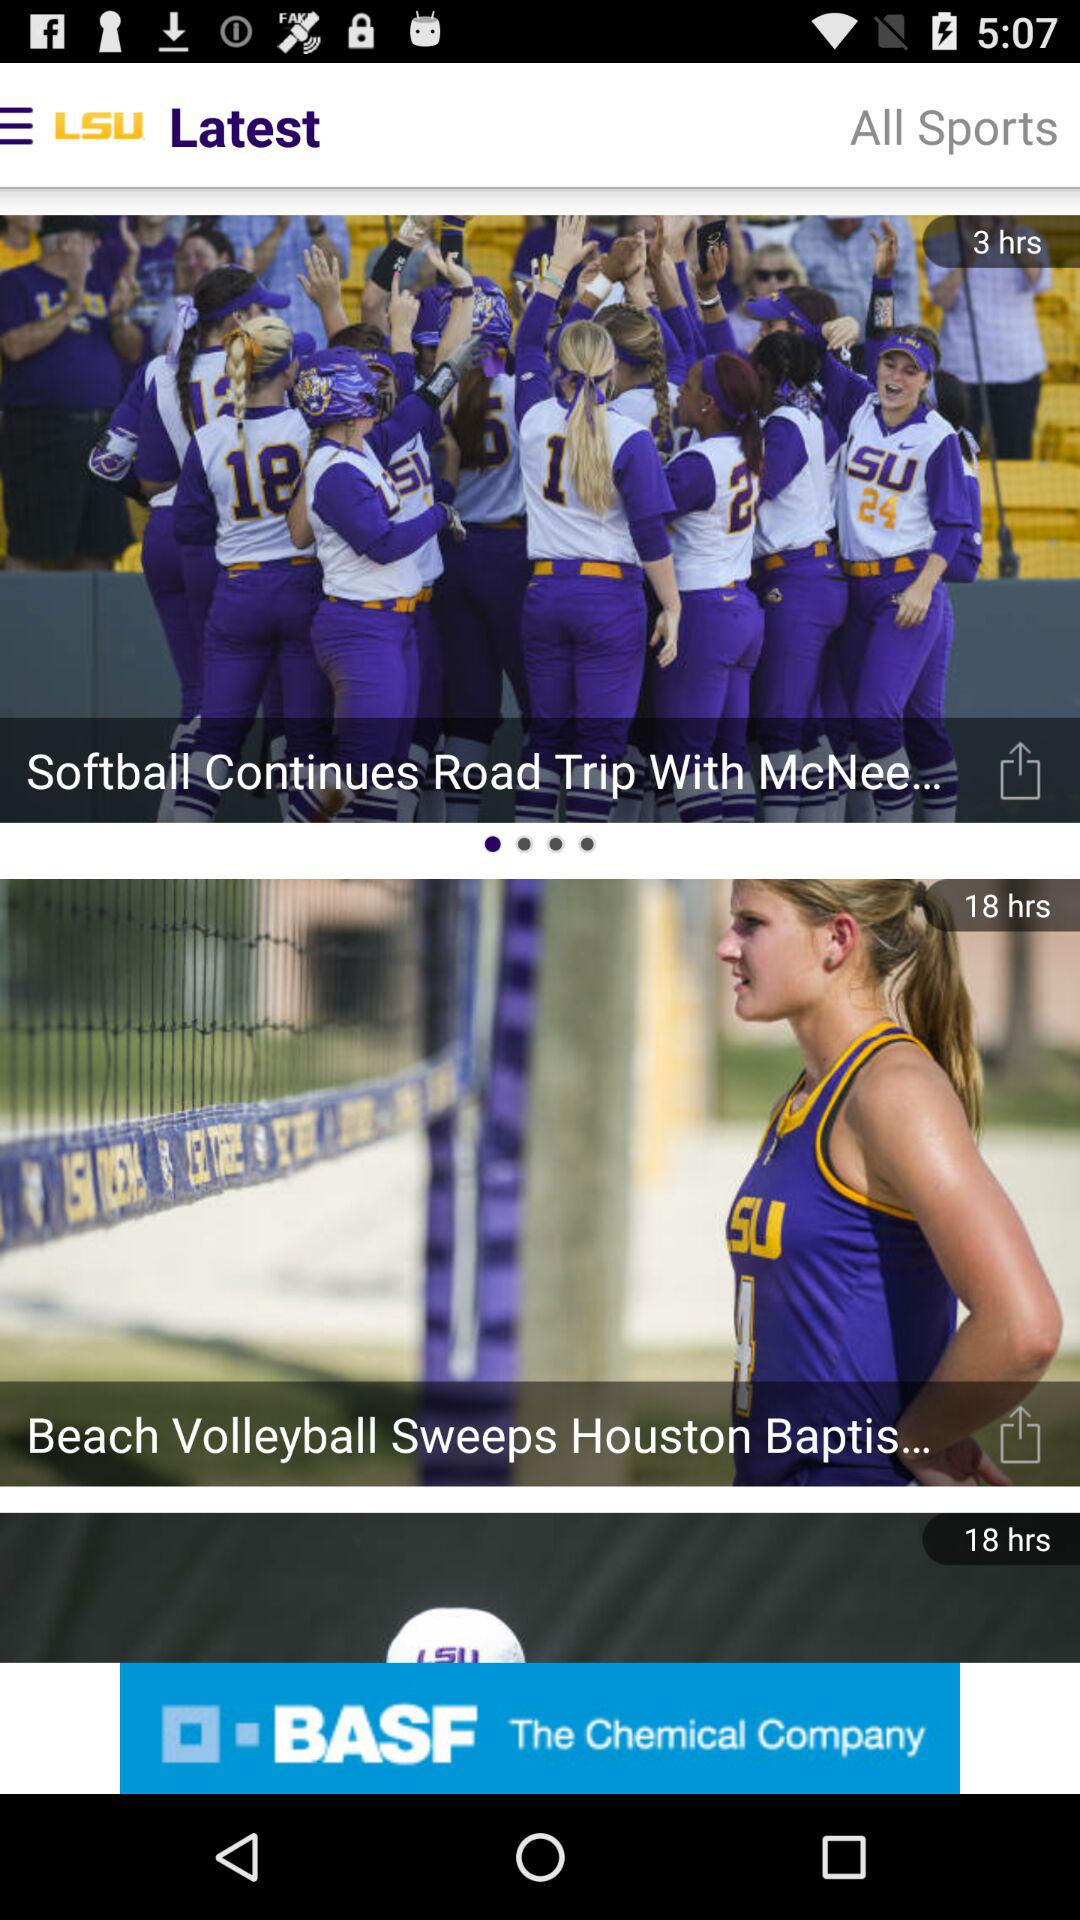What is the application name? The application name is "LSU". 